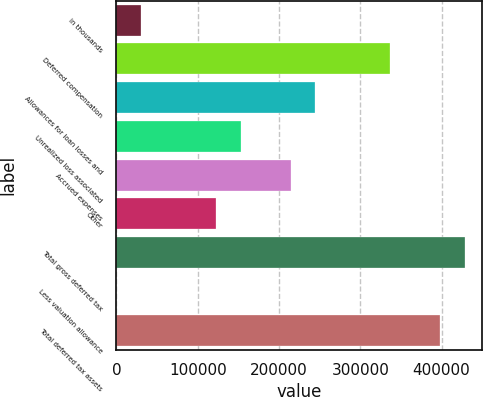Convert chart. <chart><loc_0><loc_0><loc_500><loc_500><bar_chart><fcel>in thousands<fcel>Deferred compensation<fcel>Allowances for loan losses and<fcel>Unrealized loss associated<fcel>Accrued expenses<fcel>Other<fcel>Total gross deferred tax<fcel>Less valuation allowance<fcel>Total deferred tax assets<nl><fcel>30611.8<fcel>336630<fcel>244824<fcel>153019<fcel>214223<fcel>122417<fcel>428435<fcel>10<fcel>397833<nl></chart> 